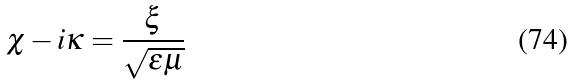<formula> <loc_0><loc_0><loc_500><loc_500>\chi - i \kappa = \frac { \xi } { \sqrt { \epsilon \mu } }</formula> 